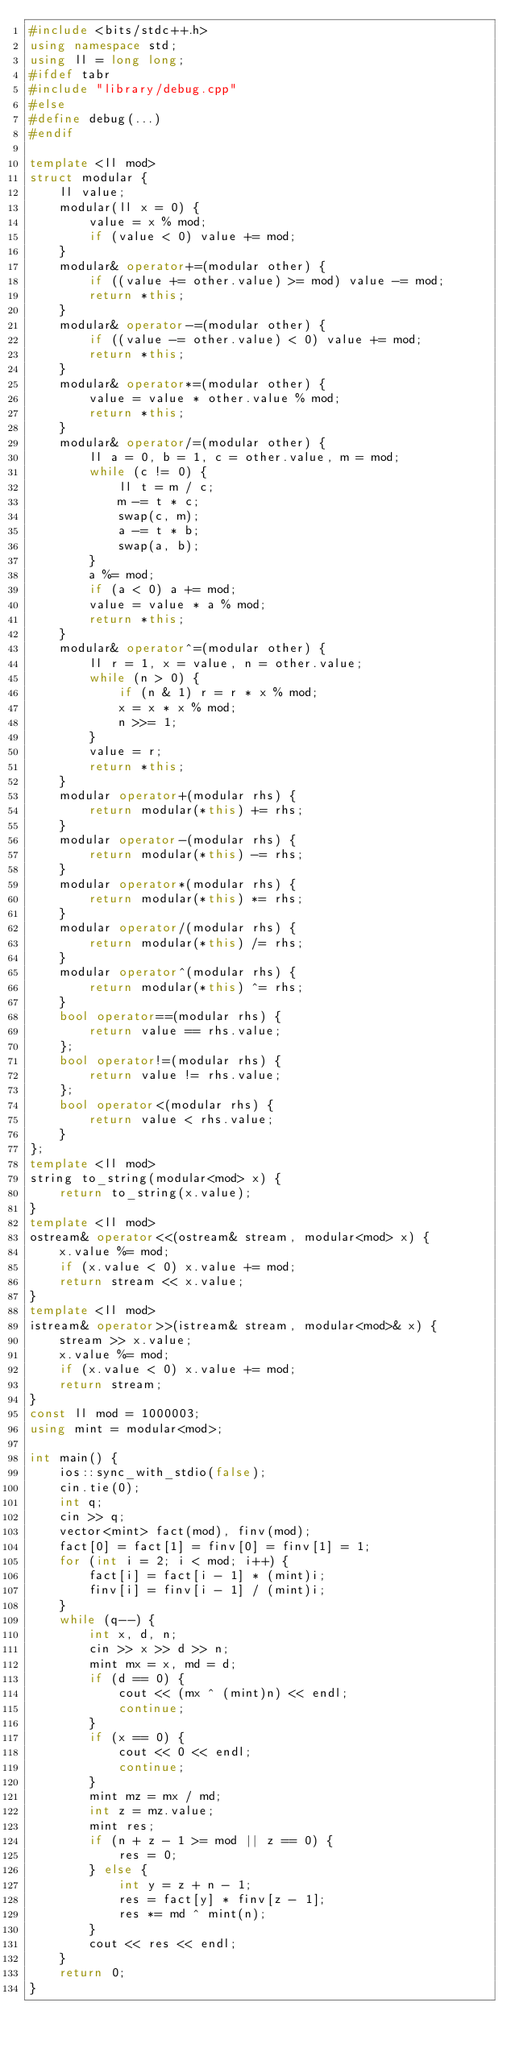<code> <loc_0><loc_0><loc_500><loc_500><_C++_>#include <bits/stdc++.h>
using namespace std;
using ll = long long;
#ifdef tabr
#include "library/debug.cpp"
#else
#define debug(...)
#endif

template <ll mod>
struct modular {
    ll value;
    modular(ll x = 0) {
        value = x % mod;
        if (value < 0) value += mod;
    }
    modular& operator+=(modular other) {
        if ((value += other.value) >= mod) value -= mod;
        return *this;
    }
    modular& operator-=(modular other) {
        if ((value -= other.value) < 0) value += mod;
        return *this;
    }
    modular& operator*=(modular other) {
        value = value * other.value % mod;
        return *this;
    }
    modular& operator/=(modular other) {
        ll a = 0, b = 1, c = other.value, m = mod;
        while (c != 0) {
            ll t = m / c;
            m -= t * c;
            swap(c, m);
            a -= t * b;
            swap(a, b);
        }
        a %= mod;
        if (a < 0) a += mod;
        value = value * a % mod;
        return *this;
    }
    modular& operator^=(modular other) {
        ll r = 1, x = value, n = other.value;
        while (n > 0) {
            if (n & 1) r = r * x % mod;
            x = x * x % mod;
            n >>= 1;
        }
        value = r;
        return *this;
    }
    modular operator+(modular rhs) {
        return modular(*this) += rhs;
    }
    modular operator-(modular rhs) {
        return modular(*this) -= rhs;
    }
    modular operator*(modular rhs) {
        return modular(*this) *= rhs;
    }
    modular operator/(modular rhs) {
        return modular(*this) /= rhs;
    }
    modular operator^(modular rhs) {
        return modular(*this) ^= rhs;
    }
    bool operator==(modular rhs) {
        return value == rhs.value;
    };
    bool operator!=(modular rhs) {
        return value != rhs.value;
    };
    bool operator<(modular rhs) {
        return value < rhs.value;
    }
};
template <ll mod>
string to_string(modular<mod> x) {
    return to_string(x.value);
}
template <ll mod>
ostream& operator<<(ostream& stream, modular<mod> x) {
    x.value %= mod;
    if (x.value < 0) x.value += mod;
    return stream << x.value;
}
template <ll mod>
istream& operator>>(istream& stream, modular<mod>& x) {
    stream >> x.value;
    x.value %= mod;
    if (x.value < 0) x.value += mod;
    return stream;
}
const ll mod = 1000003;
using mint = modular<mod>;

int main() {
    ios::sync_with_stdio(false);
    cin.tie(0);
    int q;
    cin >> q;
    vector<mint> fact(mod), finv(mod);
    fact[0] = fact[1] = finv[0] = finv[1] = 1;
    for (int i = 2; i < mod; i++) {
        fact[i] = fact[i - 1] * (mint)i;
        finv[i] = finv[i - 1] / (mint)i;
    }
    while (q--) {
        int x, d, n;
        cin >> x >> d >> n;
        mint mx = x, md = d;
        if (d == 0) {
            cout << (mx ^ (mint)n) << endl;
            continue;
        }
        if (x == 0) {
            cout << 0 << endl;
            continue;
        }
        mint mz = mx / md;
        int z = mz.value;
        mint res;
        if (n + z - 1 >= mod || z == 0) {
            res = 0;
        } else {
            int y = z + n - 1;
            res = fact[y] * finv[z - 1];
            res *= md ^ mint(n);
        }
        cout << res << endl;
    }
    return 0;
}</code> 